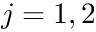<formula> <loc_0><loc_0><loc_500><loc_500>j = 1 , 2</formula> 